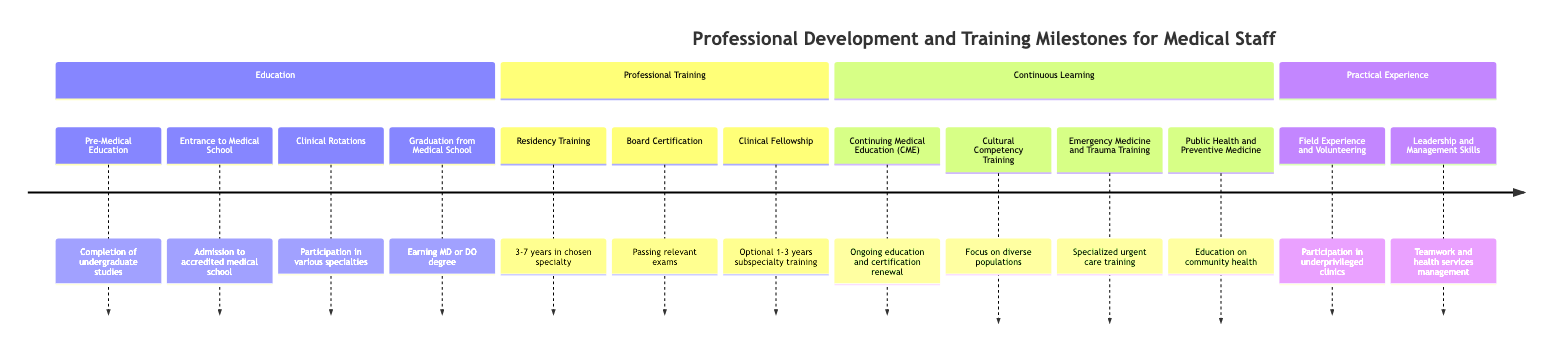What is the first milestone in the timeline? The first milestone listed in the timeline is "Pre-Medical Education". This can be directly identified as the initial point of the timeline under the "Education" section.
Answer: Pre-Medical Education How many years does residency training typically last? The timeline indicates that residency training typically lasts between 3 to 7 years. This information is specified under the "Professional Training" section.
Answer: 3 to 7 years What milestone follows Clinical Rotations in the timeline? After "Clinical Rotations", the next milestone listed is "Graduation from Medical School". This follows a sequential order in the "Education" section of the timeline.
Answer: Graduation from Medical School Which training focuses on working with diverse populations? The training that focuses on working with diverse populations is "Cultural Competency Training". This is specifically mentioned within the "Continuous Learning" section.
Answer: Cultural Competency Training What type of training involves emergency care and trauma management? The type of training that involves emergency care and trauma management is "Emergency Medicine and Trauma Training". This is detailed in the "Continuous Learning" section of the timeline.
Answer: Emergency Medicine and Trauma Training What are the two parts of the timeline that include practical experience? The two parts that include practical experience are "Field Experience and Volunteering" and "Leadership and Management Skills Development". Both are located in the "Practical Experience" section.
Answer: Field Experience and Volunteering, Leadership and Management Skills Development What is the milestone for obtaining a medical degree? The milestone for obtaining a medical degree is "Graduation from Medical School", where individuals earn their MD or DO degree, as indicated in the "Education" section.
Answer: Graduation from Medical School What is the purpose of Continuing Medical Education (CME)? The purpose of Continuing Medical Education (CME) is to provide ongoing education to stay current with medical advancements and to renew board certification, as stated in the "Continuous Learning" section.
Answer: Ongoing education to stay current with medical advancements How many years does a Clinical Fellowship typically last? A Clinical Fellowship typically lasts between 1 to 3 years, according to the information in the "Professional Training" section of the timeline.
Answer: 1 to 3 years Which milestone is primarily focused on community health improvement? The milestone focused on community health improvement is "Public Health and Preventive Medicine Training". This is explicitly mentioned in the "Continuous Learning" section of the timeline.
Answer: Public Health and Preventive Medicine Training 